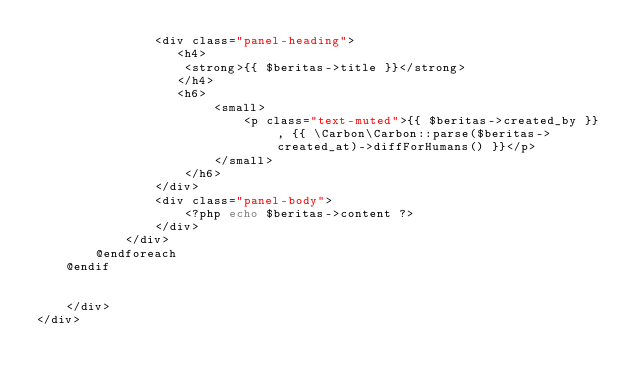<code> <loc_0><loc_0><loc_500><loc_500><_PHP_>                <div class="panel-heading">
                   <h4>
                    <strong>{{ $beritas->title }}</strong>
                   </h4> 
                   <h6>                    
                        <small>
                            <p class="text-muted">{{ $beritas->created_by }} , {{ \Carbon\Carbon::parse($beritas->created_at)->diffForHumans() }}</p>
                        </small>
                    </h6>
                </div>
                <div class="panel-body">
                    <?php echo $beritas->content ?>
                </div>
            </div>
        @endforeach        
    @endif
        
        
    </div>
</div>
</code> 